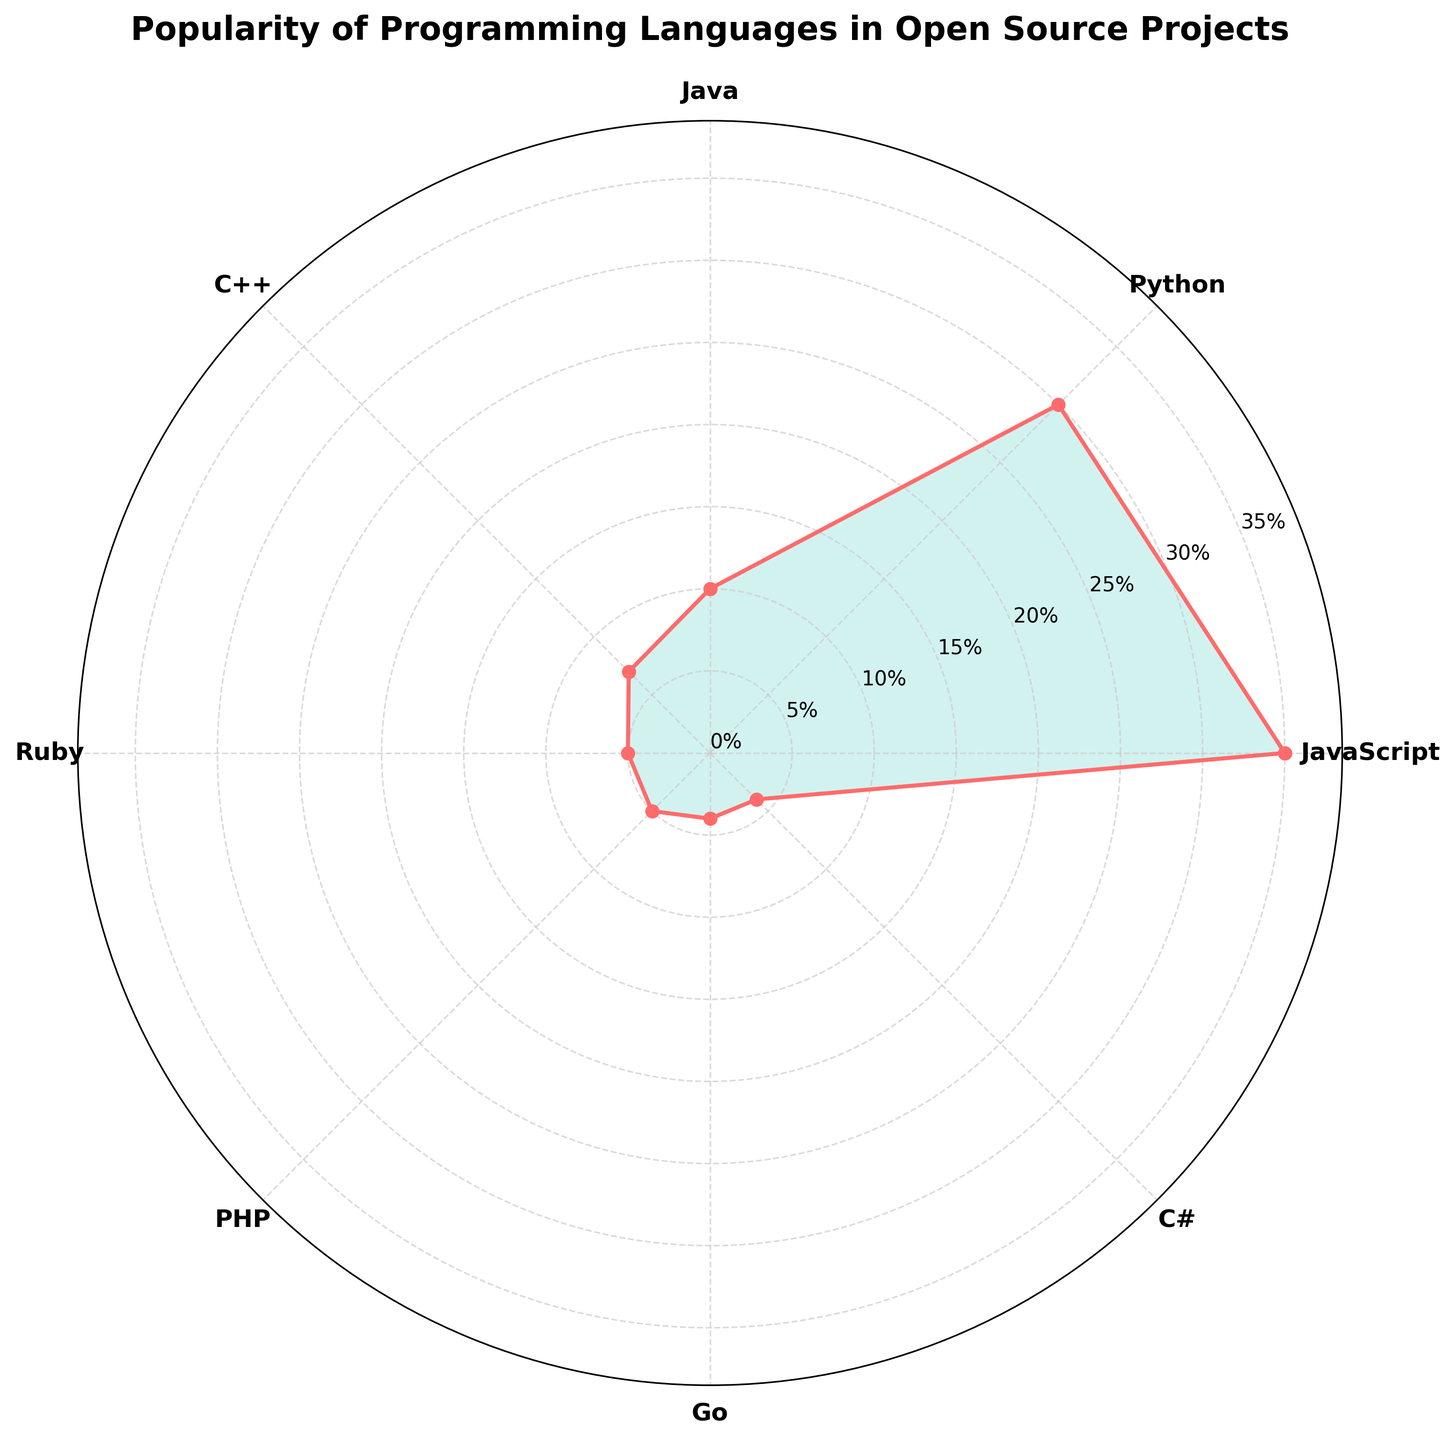What is the title of the chart? The title can be found at the top center of the chart. It is written in bold and slightly larger font than the other text on the chart.
Answer: Popularity of Programming Languages in Open Source Projects How many programming languages are represented in the chart? Count the number of unique labels around the chart. Each label represents a different programming language.
Answer: 8 Which programming language has the highest popularity? Look at the language that extends the farthest from the center of the chart. This indicates the highest percentage.
Answer: JavaScript What are the two least popular programming languages in the chart? Identify the languages with the shortest radial length from the center, indicating the lowest percentage values.
Answer: Go, C# How much more popular is Python compared to C++? Find the percentage values for Python and C++, then calculate the difference between these two values.
Answer: 23% What is the total percentage for Java and Ruby combined? Add the percentage values for Java and Ruby by summing their individual popularity percentages.
Answer: 15% Is Ruby more or less popular than PHP? Compare the radial lengths or percentage values for both Ruby and PHP to determine the relationship.
Answer: Equal Which slice has a larger percentage: C++ or Go? Compare the radial lengths of the slices for C++ and Go. The longer one represents a larger percentage.
Answer: C++ What is the average popularity percentage of all the languages combined? Sum all the popularity percentages of the languages, then divide by the total number of languages to get the average. The sum is 100%, and there are 8 languages, so the average is 100/8.
Answer: 12.5% What is the median popularity value of the programming languages? First, list all percentage values in ascending order: 4, 4, 5, 5, 7, 10, 30, 35. Then find the middle value. If there is an even number of values, the median is the average of the two central numbers. So, (5 + 7) / 2.
Answer: 6% 